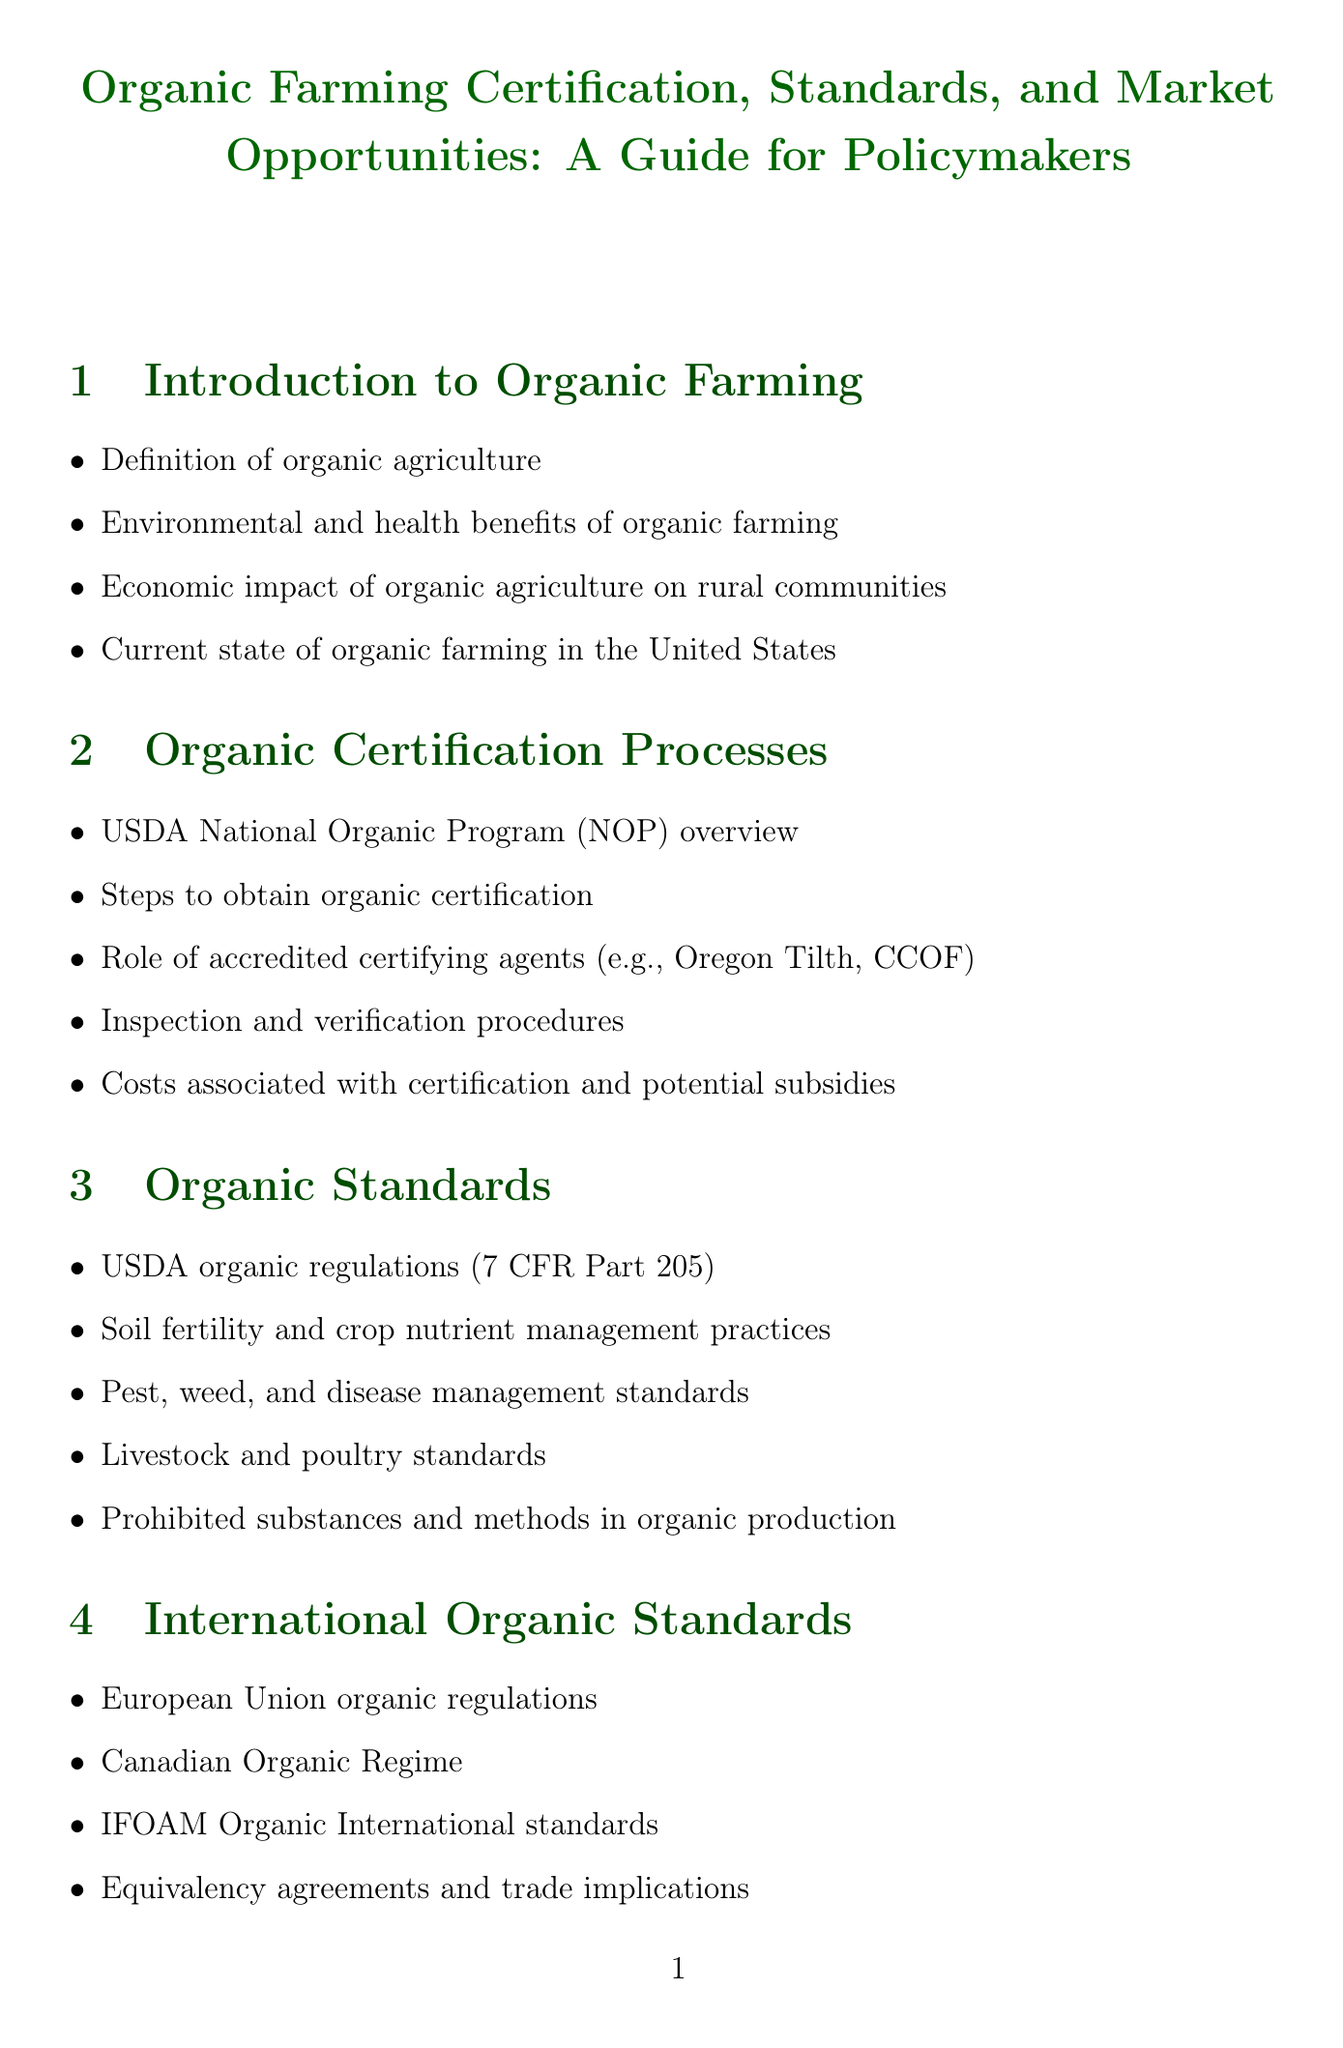what is the definition of organic agriculture? The definition of organic agriculture is outlined in the Introduction to Organic Farming section of the document.
Answer: organic agriculture what program oversees organic certification in the U.S.? The USDA National Organic Program (NOP) overview provides information about the certifying program in the U.S.
Answer: USDA National Organic Program what are two key standards required for organic livestock? The content under Organic Standards mentions requirements for organic livestock practices.
Answer: livestock or poultry standards what are the financial incentives mentioned for transitioning to organic farming? The Policy Considerations section lists financial incentives as a means to promote organic farming.
Answer: financial incentives which organizations are listed as key stakeholders in the Resources for Policymakers section? The document specifies organizations involved in organic agriculture and policy-making in this section.
Answer: Organic Trade Association, National Organic Coalition how do consumer demand trends impact organic market size? This reasoning involves the correlation between consumer demand and market growth projections discussed in the Market Opportunities section.
Answer: consumer demand trends what is one challenge in organic farming related to seed supply? The Challenges and Solutions in Organic Farming section addresses issues regarding organic seed procurement.
Answer: adequate organic seed supply how many case studies are included in the document? The Case Studies section lists specific examples relevant to organic farming practices.
Answer: four what is the emerging certification mentioned in the Future of Organic Agriculture section? The Future of Organic Agriculture section discusses new types of certifications in the field.
Answer: Regenerative Organic Certified 